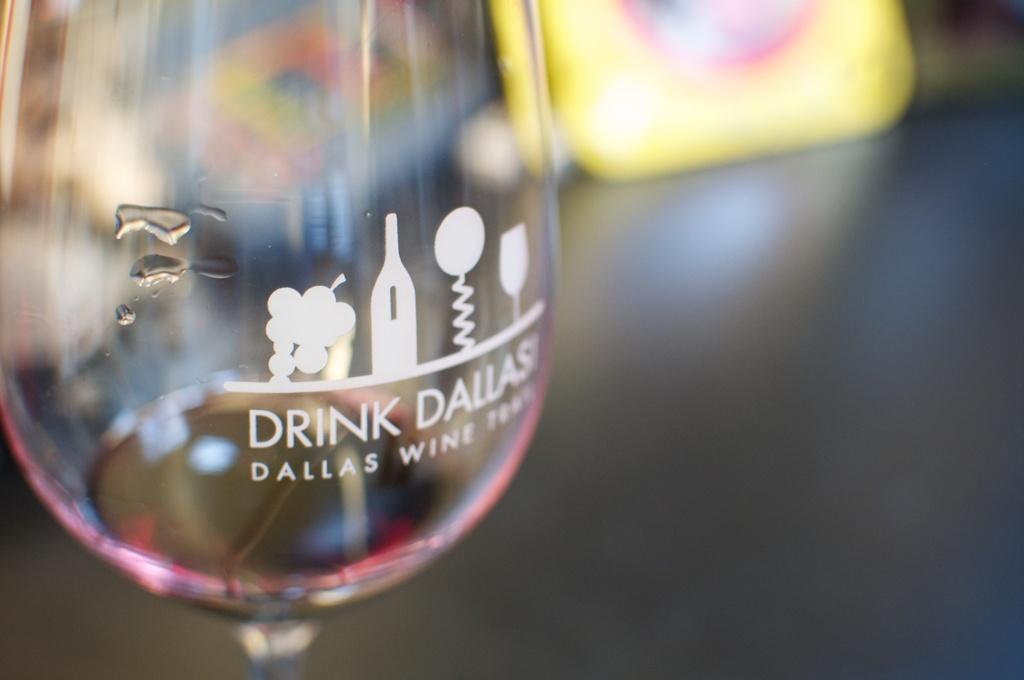Please provide a concise description of this image. On the left of this picture we can see a glass containing some portion of drink and we can see the text and some pictures on the glass. The background of the image is blurry and we can see some objects in the background. 